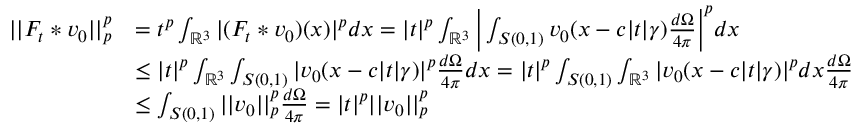Convert formula to latex. <formula><loc_0><loc_0><loc_500><loc_500>\begin{array} { r l } { | | F _ { t } * v _ { 0 } | | _ { p } ^ { p } } & { = t ^ { p } \int _ { \mathbb { R } ^ { 3 } } | ( F _ { t } * v _ { 0 } ) ( x ) | ^ { p } d x = | t | ^ { p } \int _ { \mathbb { R } ^ { 3 } } \left | \int _ { S ( 0 , 1 ) } v _ { 0 } ( x - c | t | \gamma ) \frac { d \Omega } { 4 \pi } \right | ^ { p } d x } \\ & { \leq | t | ^ { p } \int _ { \mathbb { R } ^ { 3 } } \int _ { S ( 0 , 1 ) } | v _ { 0 } ( x - c | t | \gamma ) | ^ { p } \frac { d \Omega } { 4 \pi } d x = | t | ^ { p } \int _ { S ( 0 , 1 ) } \int _ { \mathbb { R } ^ { 3 } } | v _ { 0 } ( x - c | t | \gamma ) | ^ { p } d x \frac { d \Omega } { 4 \pi } } \\ & { \leq \int _ { S ( 0 , 1 ) } | | v _ { 0 } | | _ { p } ^ { p } \frac { d \Omega } { 4 \pi } = | t | ^ { p } | | v _ { 0 } | | _ { p } ^ { p } } \end{array}</formula> 